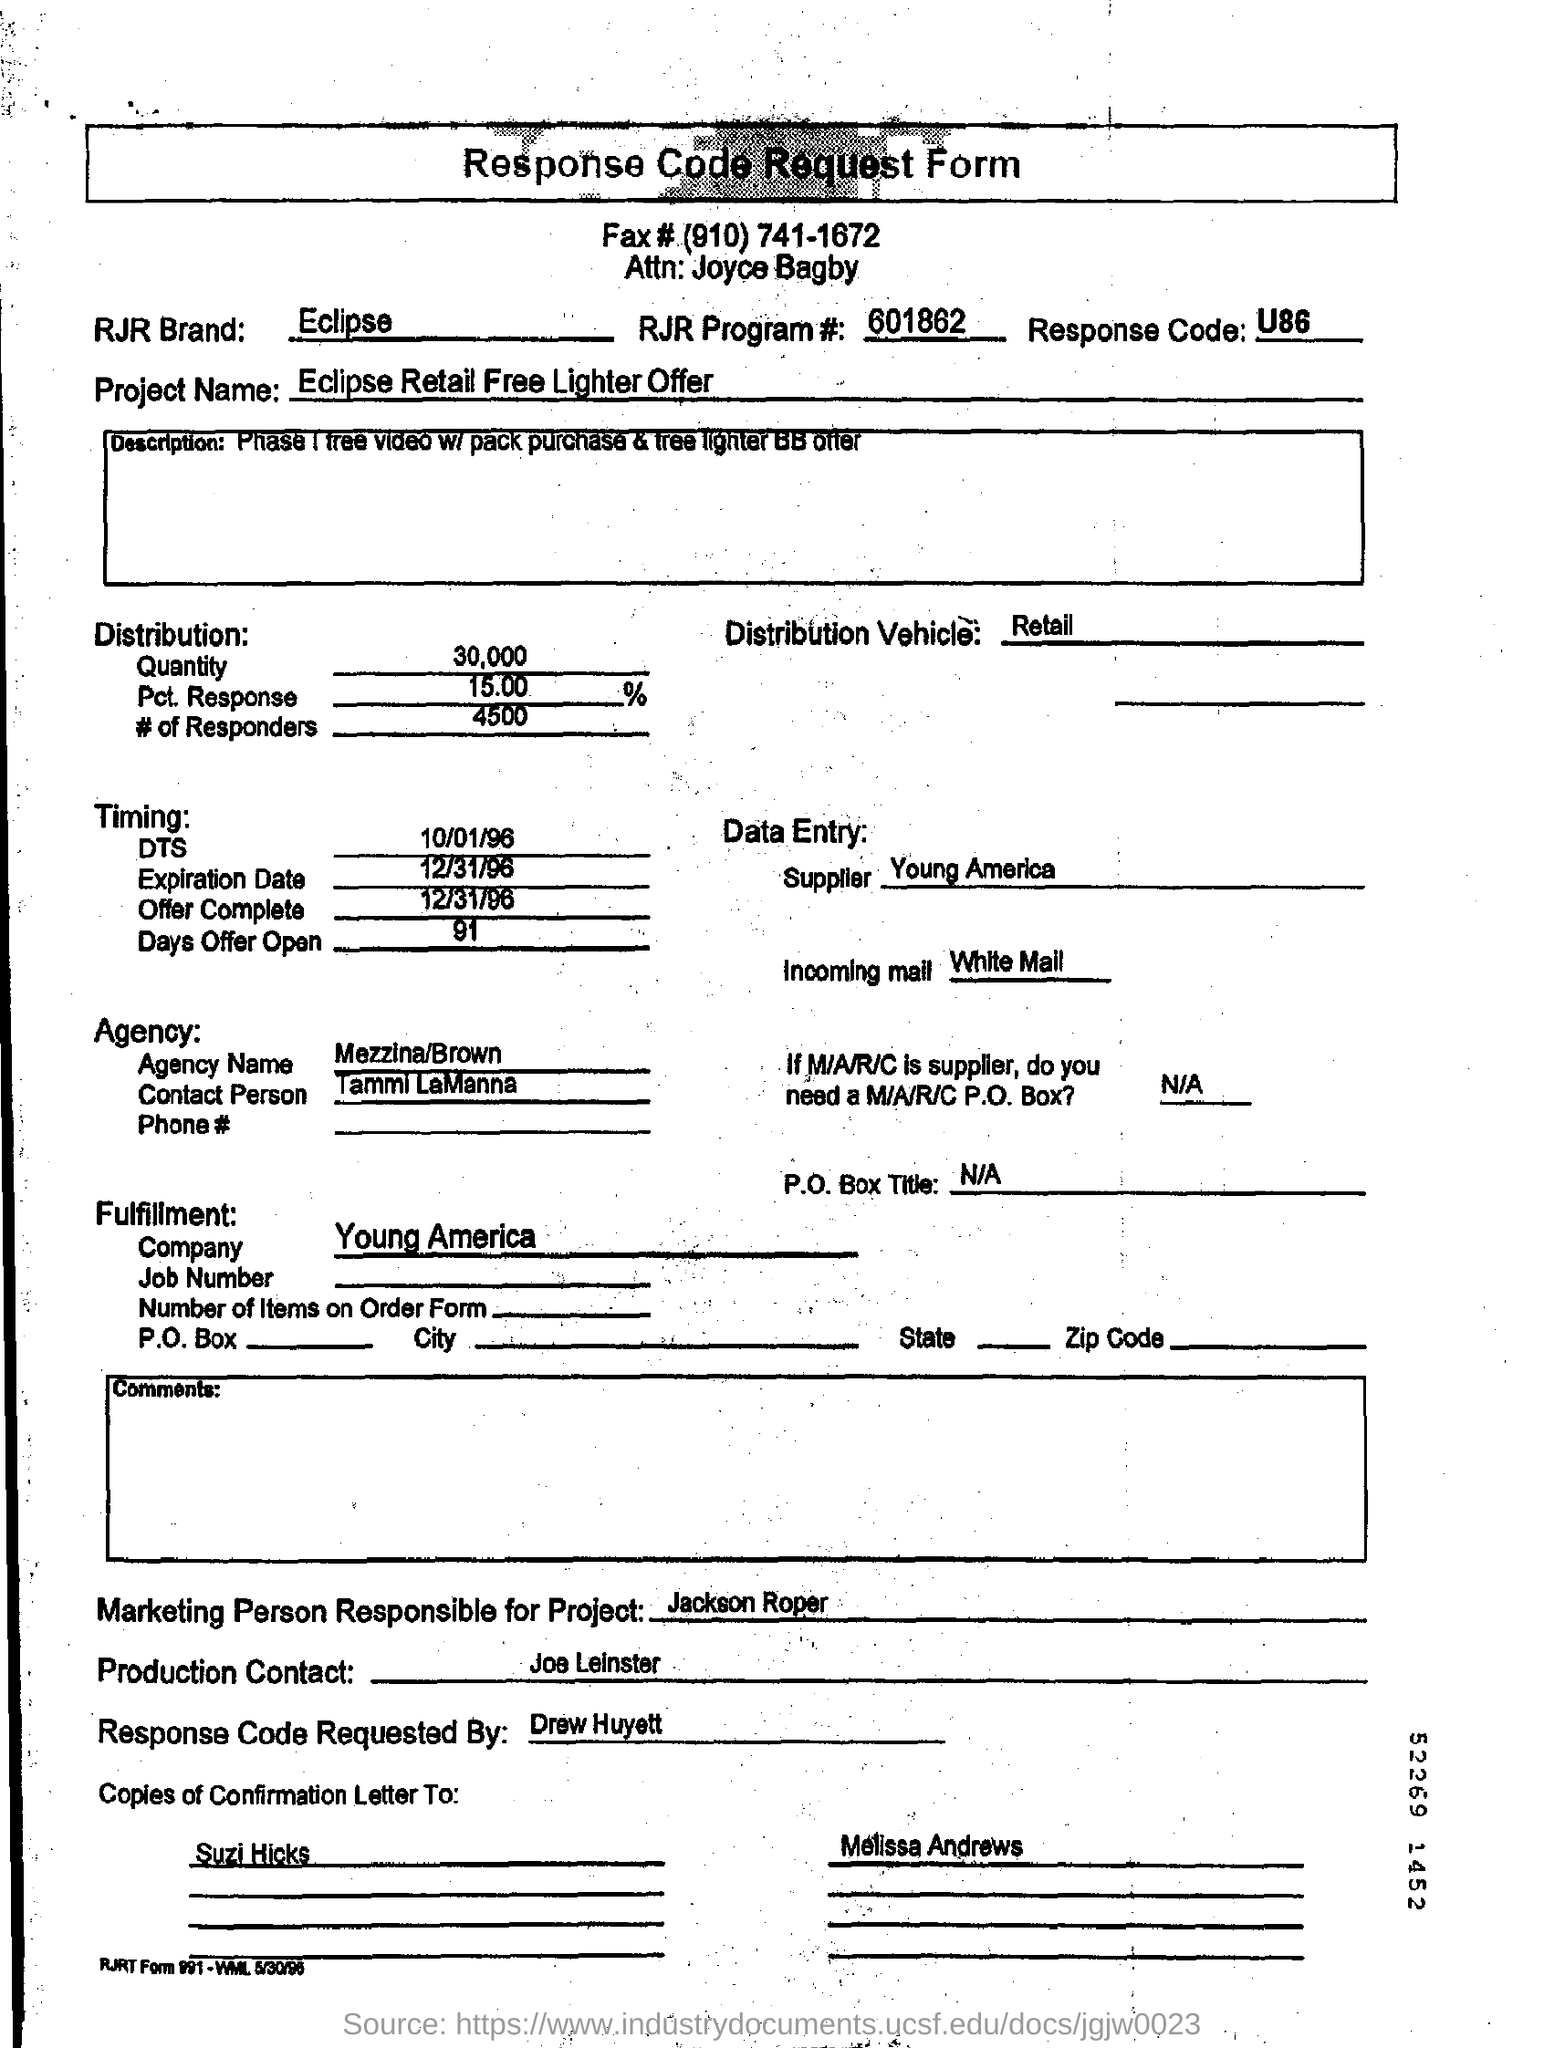Can you tell me more about the project mentioned in the form? The project mentioned in the form is titled 'Eclipse Retail Free Lighter Offer'. It appears to be a promotional campaign involving a giveaway connected to the purchase of a specific product. 